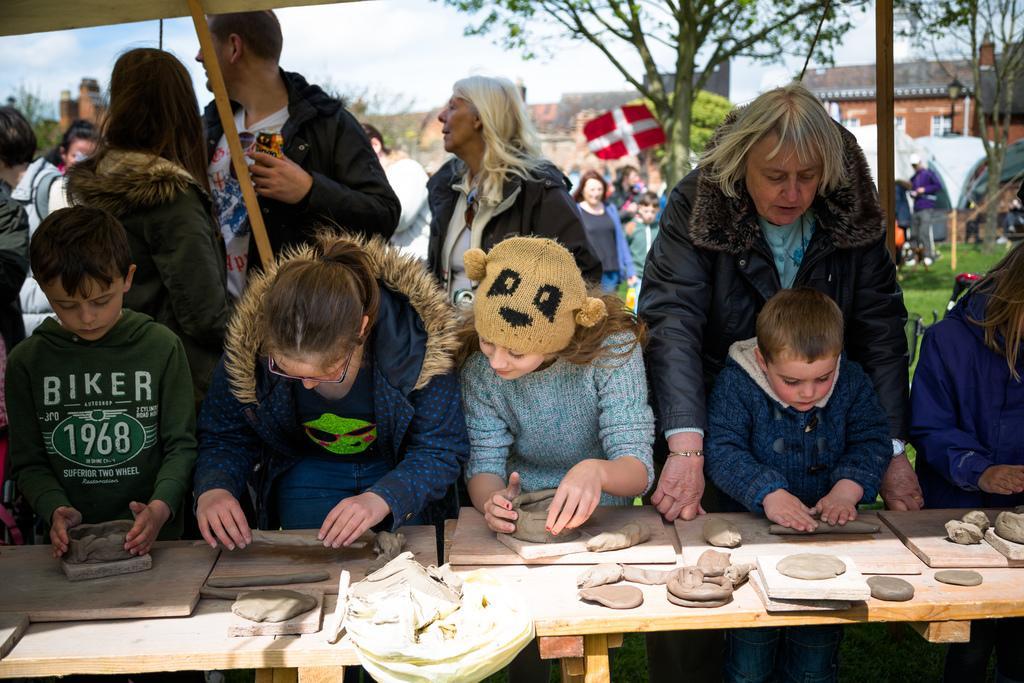Could you give a brief overview of what you see in this image? There is a group of people. Some people are standing and some people are walking. There is a table. They are making bowl with mud. We can see in the background there is a sky,tree and buildings. 